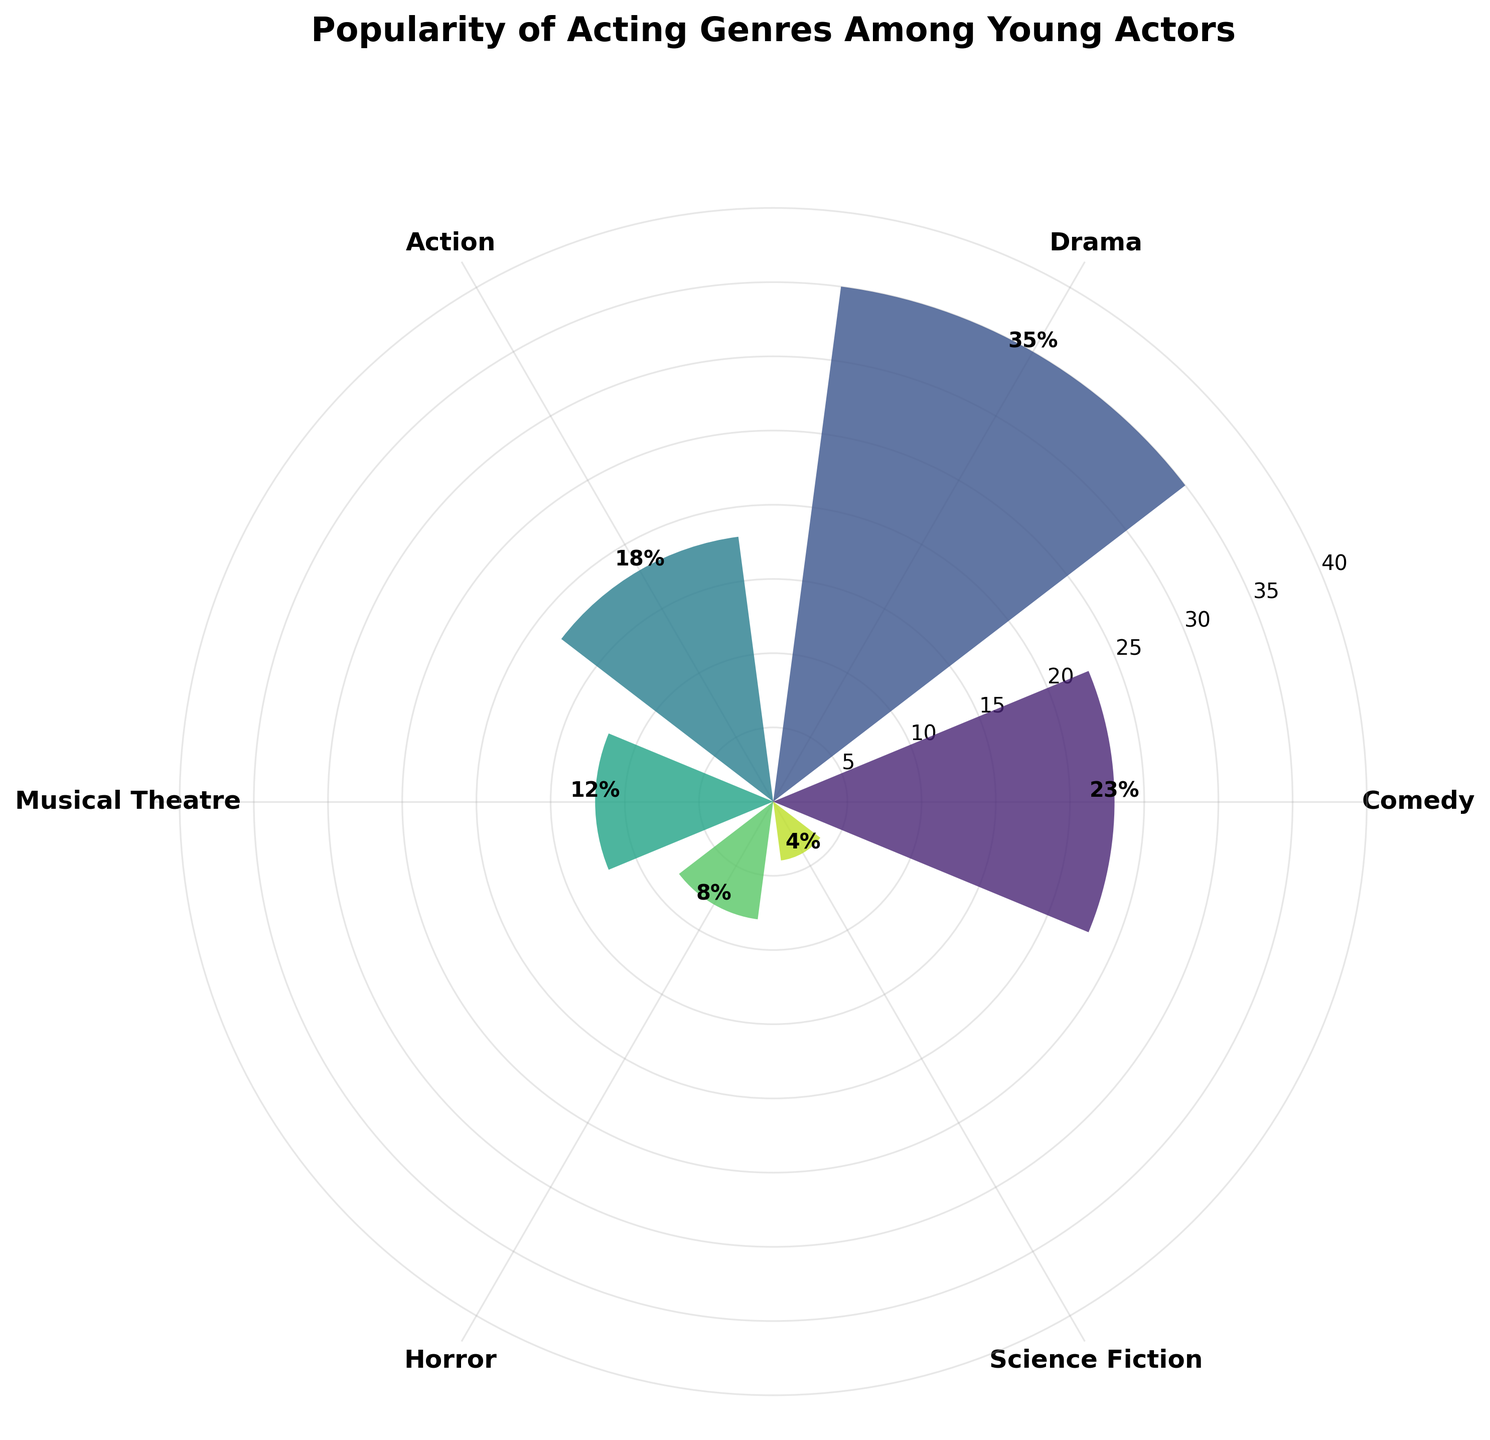Which genre is the most popular among young actors? By looking at the bars, the "Drama" genre has the tallest bar, indicating it's the most popular.
Answer: Drama Which genre has the lowest popularity among young actors? The "Science Fiction" genre has the shortest bar, indicating it has the lowest popularity.
Answer: Science Fiction What is the percentage popularity of the Comedy genre? The bar labeled "Comedy" is at 23%, which is also annotated above the bar.
Answer: 23% What is the total percentage for genres with less than 20% popularity? Sum the percentages of Action (18%), Musical Theatre (12%), Horror (8%), and Science Fiction (4%) to get a total of 18 + 12 + 8 + 4 = 42%.
Answer: 42% Which genres have a popularity greater than 15%? Bars labeled "Comedy" (23%), "Drama" (35%), and "Action" (18%) are each greater than 15%.
Answer: Comedy, Drama, Action How many genres have a popularity greater than the average popularity of all genres? Calculate the average popularity sum(23+35+18+12+8+4)/6 = 100/6 ≈ 16.67%. Compare this with each genre: Comedy (23%), Drama (35%), and Action (18%) are greater than 16.67%.
Answer: 3 What is the most significant difference in popularity between two consecutive genres? Look at the differences: Drama-Comedy (35-23=12%), Action-Drama (35-18=17%), Musical Theatre-Action (18-12=6%), Horror-Musical Theatre (12-8=4%), Science Fiction-Horror (8-4=4%). The largest difference is between Drama and Action (17%).
Answer: 17% What percentage of genres fall below 10% popularity? Horror (8%) and Science Fiction (4%) are the only genres below 10%, so 2 out of 6 genres. (2/6) * 100 = 33.3%.
Answer: 33.3% What is the cumulative percentage of the Musical Theatre, Horror, and Science Fiction genres? Sum of these percentages is 12% + 8% + 4% = 24%.
Answer: 24% What color palette is used in the plot? The plot uses a gradient of the Viridis color palette, moving from darker to lighter shades.
Answer: Viridis 